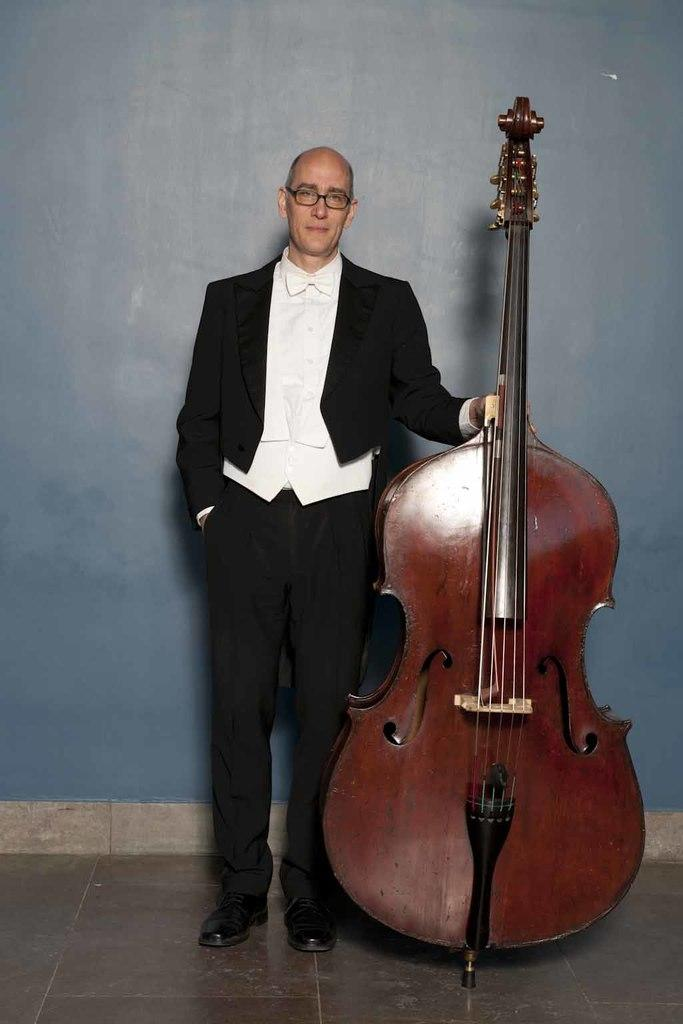What is present in the image alongside the man? The man is standing beside a violin. What is the man doing with the violin? The man is placing a hand on the violin. Can you see any drops of water on the violin in the image? There is no mention of any drops of water on the violin in the image. Is there a playground visible in the image? There is no mention of a playground in the image. Are there any roses present in the image? There is no mention of any roses in the image. 